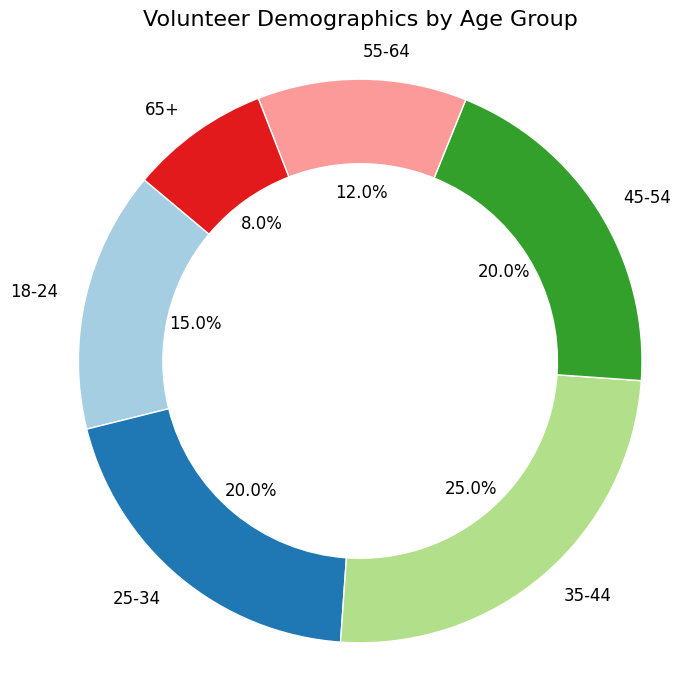Which age group has the highest percentage of volunteers? By examining the chart, the segment representing the '35-44' age group looks the largest, indicating the highest percentage.
Answer: 35-44 What is the combined percentage of volunteers aged 18-34? The '18-24' group has 15% and the '25-34' group has 20%. Adding these percentages together, 15% + 20% = 35%.
Answer: 35% Which age group has the lowest percentage of volunteers? By looking at the chart, the '65+' segment is the smallest, which means it has the lowest percentage.
Answer: 65+ How much larger is the percentage of volunteers aged 45-54 compared to those aged 65+? The '45-54' group has 20% and the '65+' group has 8%. Subtracting the lower percentage from the higher percentage, 20% - 8% = 12%.
Answer: 12% What is the total percentage of volunteers aged 45 and above? Add the percentages for groups '45-54', '55-64', and '65+', which are 20%, 12%, and 8%, respectively. 20% + 12% + 8% = 40%.
Answer: 40% Are there more volunteers aged 25-34 or 55-64? The '25-34' segment is larger with 20% compared to the '55-64' segment which has 12%. Therefore, there are more volunteers aged 25-34.
Answer: 25-34 Which color represents the '18-24' age group, and how does it compare visually to the '65+' age group? The '18-24' age group is represented by a specific color in the ring chart, and the segment is visually larger compared to the '65+' age group, indicating a higher percentage.
Answer: Specified color, larger How do the combined percentages of volunteers aged 25-34 and 35-44 compare to the total percentage of volunteers aged 45-64? The combined percentage for '25-34' and '35-44' is 20% + 25% = 45%. The combined percentage for '45-54' and '55-64' is 20% + 12% = 32%. Thus, 45% - 32% = 13%. The '25-34' and '35-44' group combined is 13% more.
Answer: 13% more Is the percentage of volunteers aged 35-44 higher or lower than twice the percentage of those aged 18-24? The '35-44' age group has 25%, and twice the percentage of the '18-24' group is 15% * 2 = 30%. Since 25% is less than 30%, it is lower.
Answer: Lower What is the average percentage of all the age groups? Add up the percentages of all age groups which sum to 100%, then divide by the number of age groups, which is 6. So, 100% / 6 = 16.67%.
Answer: 16.67% 